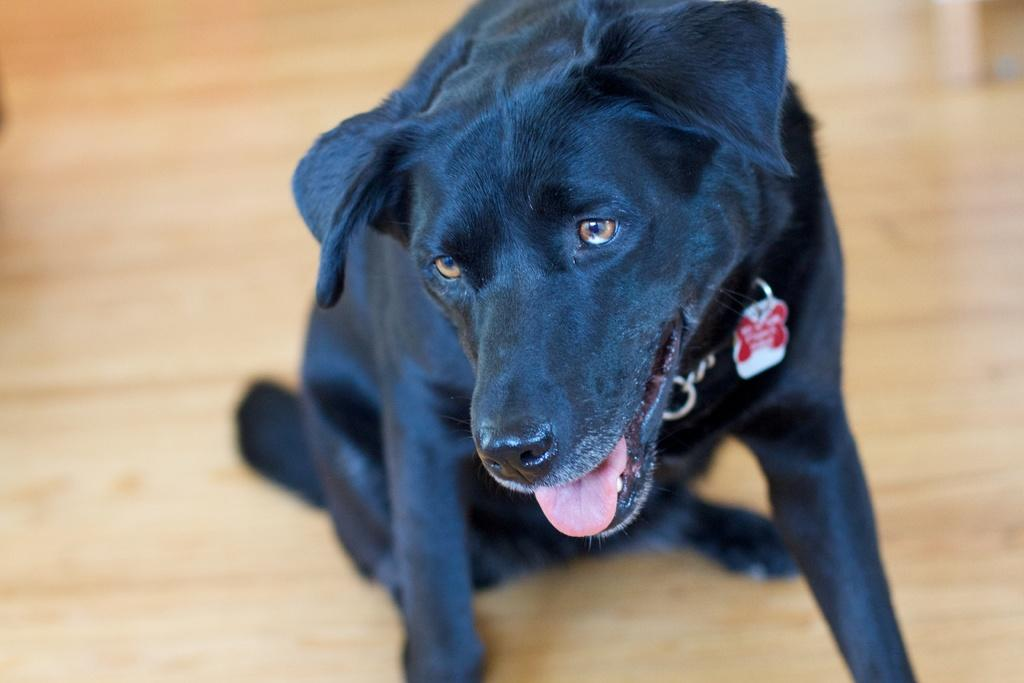What type of animal is present in the image? There is a dog in the image. Where is the dog located in the image? The dog is on the floor. Can you see the dog taking a flight in the image? No, there is no flight or any indication of the dog flying in the image. 